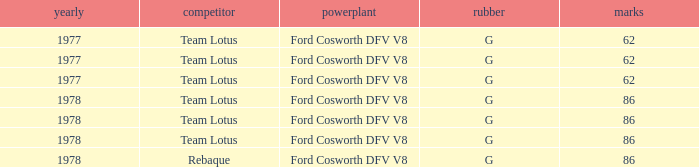Could you help me parse every detail presented in this table? {'header': ['yearly', 'competitor', 'powerplant', 'rubber', 'marks'], 'rows': [['1977', 'Team Lotus', 'Ford Cosworth DFV V8', 'G', '62'], ['1977', 'Team Lotus', 'Ford Cosworth DFV V8', 'G', '62'], ['1977', 'Team Lotus', 'Ford Cosworth DFV V8', 'G', '62'], ['1978', 'Team Lotus', 'Ford Cosworth DFV V8', 'G', '86'], ['1978', 'Team Lotus', 'Ford Cosworth DFV V8', 'G', '86'], ['1978', 'Team Lotus', 'Ford Cosworth DFV V8', 'G', '86'], ['1978', 'Rebaque', 'Ford Cosworth DFV V8', 'G', '86']]} What is the Motor that has a Focuses bigger than 62, and a Participant of rebaque? Ford Cosworth DFV V8. 